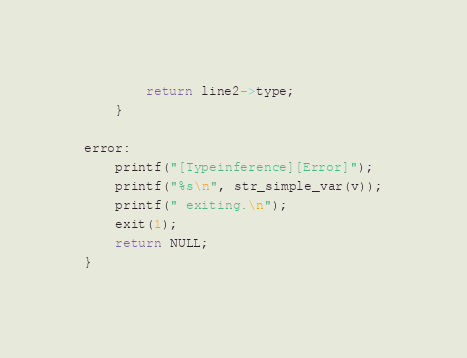<code> <loc_0><loc_0><loc_500><loc_500><_C_>		return line2->type;
	}
	
error:
	printf("[Typeinference][Error]");
	printf("%s\n", str_simple_var(v));
	printf(" exiting.\n");
	exit(1);
	return NULL;
}
</code> 